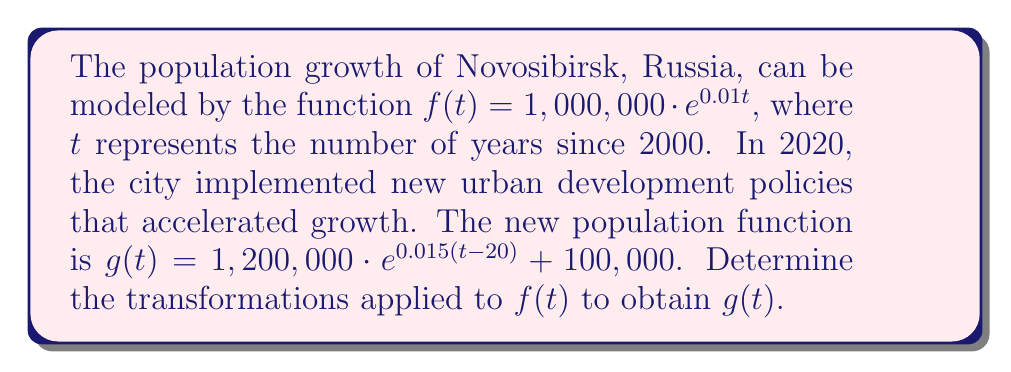What is the answer to this math problem? To determine the transformations applied to $f(t)$ to obtain $g(t)$, we need to analyze the changes in each part of the function:

1. Vertical stretch:
   The coefficient of $e$ changed from 1,000,000 to 1,200,000.
   This represents a vertical stretch by a factor of 1.2.

2. Horizontal shift:
   The $t$ inside the exponential changed to $(t-20)$.
   This represents a horizontal shift 20 units to the right.

3. Change in growth rate:
   The coefficient of $t$ in the exponent changed from 0.01 to 0.015.
   This represents an increase in the growth rate.

4. Vertical shift:
   The addition of 100,000 at the end of $g(t)$ represents a vertical shift up by 100,000 units.

To transform $f(t)$ into $g(t)$, we apply these transformations in the following order:

a) Stretch vertically by a factor of 1.2
b) Shift horizontally 20 units right
c) Increase the growth rate from 0.01 to 0.015
d) Shift vertically up by 100,000 units

Mathematically, this can be expressed as:
$$g(t) = 1.2 \cdot f(t-20) \cdot \frac{e^{0.015t}}{e^{0.01t}} + 100,000$$
Answer: The transformations applied to $f(t)$ to obtain $g(t)$ are:
1. Vertical stretch by a factor of 1.2
2. Horizontal shift 20 units right
3. Increase in growth rate from 0.01 to 0.015
4. Vertical shift up by 100,000 units 